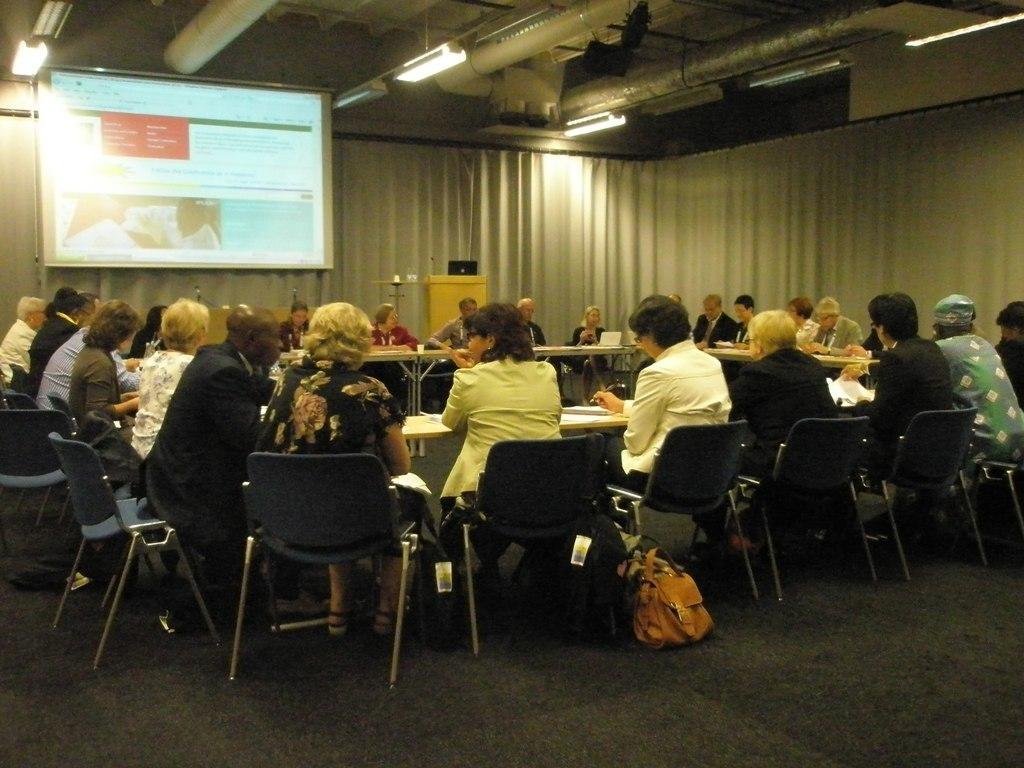How would you summarize this image in a sentence or two? This is a conference room where we can see a big screen and some lights and also some group of people sitting on the chairs in front of the desk on which there are some papers, laptops. 